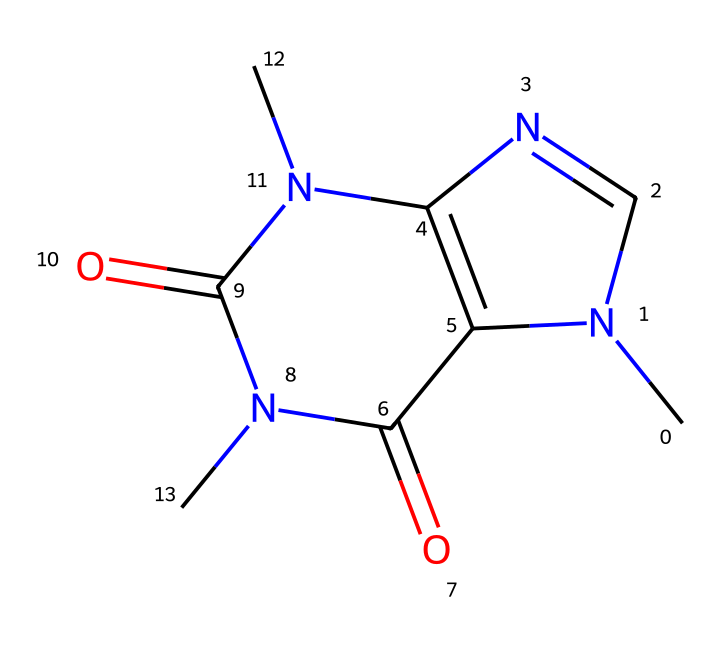What is the molecular formula of caffeine? To determine the molecular formula, we need to count the number of each type of atom in the SMILES representation. Analyzing the structure, we find there are 8 carbons (C), 10 hydrogens (H), 4 nitrogens (N), and 2 oxygens (O), which gives us C8H10N4O2.
Answer: C8H10N4O2 How many nitrogen atoms are present in the caffeine structure? From the SMILES, we can see the presence of four occurrences of the nitrogen (N) atom. By simply counting the 'N' characters in the SMILES string, we confirm there are four nitrogen atoms.
Answer: 4 What type of chemical compound is caffeine classified as? Caffeine is classified as an alkaloid due to the presence of nitrogen atoms in its structure and its biological activity affecting the nervous system. Alkaloids are known for their pharmacological properties.
Answer: alkaloid How many rings are present in the caffeine molecular structure? Analyzing the SMILES representation, we can observe that there are two cyclic groups indicated by numbers that denote the beginning and end of rings. Therefore, there are two rings present in the structure.
Answer: 2 Does caffeine contain any double bonds? In examining the structure, we can identify double bonds by looking for '=' signs in the SMILES. There are multiple '=' symbols present, indicating that double bonds exist in the molecular structure.
Answer: yes What are the functional groups present in caffeine? By analyzing the SMILES structure, we can identify amine groups (due to nitrogen) and carbonyl groups (from the presence of the double-bonded oxygen in the structure). This combination reveals both functional group types present in caffeine.
Answer: amine, carbonyl 